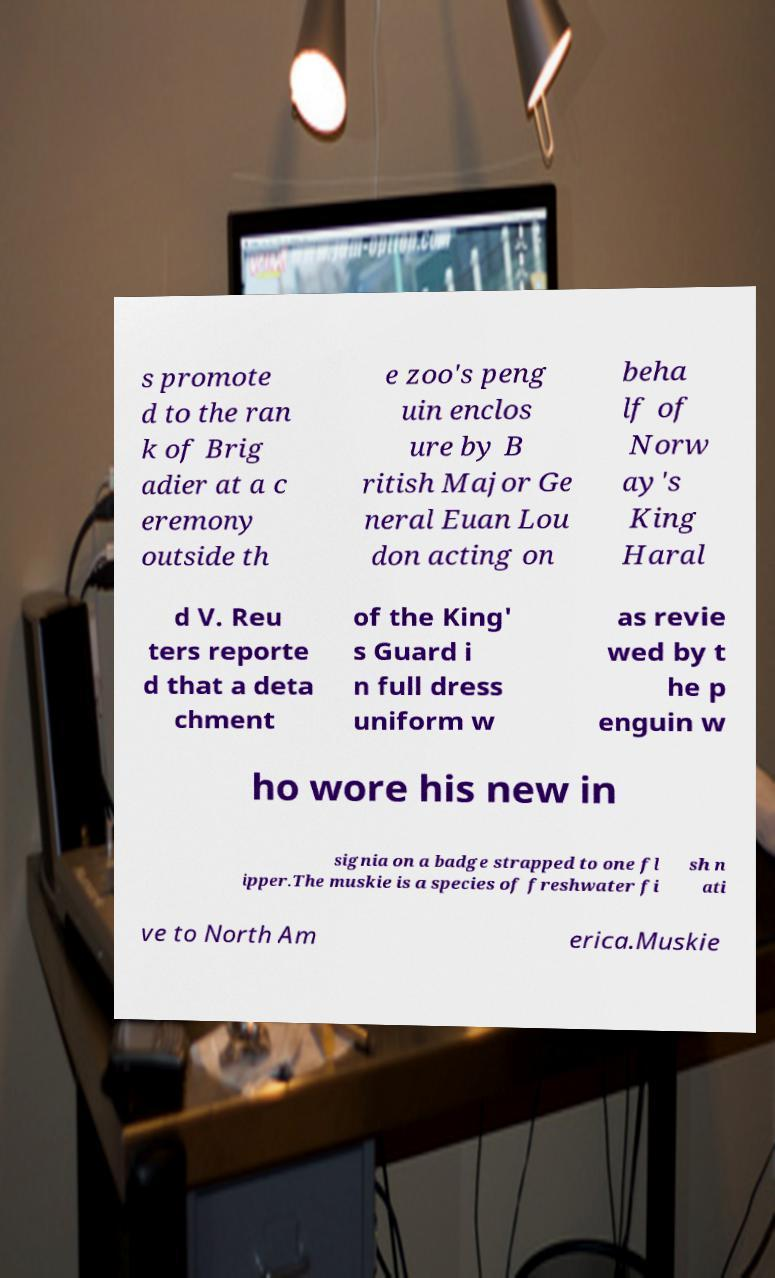Please read and relay the text visible in this image. What does it say? s promote d to the ran k of Brig adier at a c eremony outside th e zoo's peng uin enclos ure by B ritish Major Ge neral Euan Lou don acting on beha lf of Norw ay's King Haral d V. Reu ters reporte d that a deta chment of the King' s Guard i n full dress uniform w as revie wed by t he p enguin w ho wore his new in signia on a badge strapped to one fl ipper.The muskie is a species of freshwater fi sh n ati ve to North Am erica.Muskie 